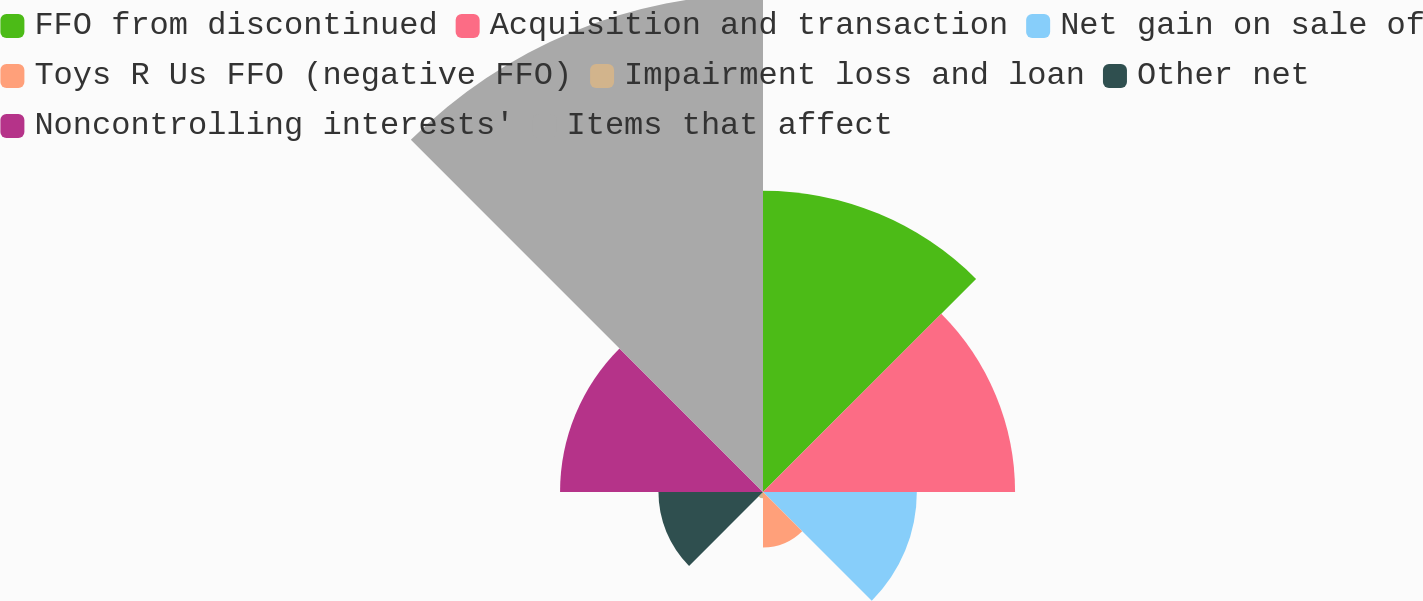<chart> <loc_0><loc_0><loc_500><loc_500><pie_chart><fcel>FFO from discontinued<fcel>Acquisition and transaction<fcel>Net gain on sale of<fcel>Toys R Us FFO (negative FFO)<fcel>Impairment loss and loan<fcel>Other net<fcel>Noncontrolling interests'<fcel>Items that affect<nl><fcel>19.14%<fcel>16.01%<fcel>9.77%<fcel>3.52%<fcel>0.4%<fcel>6.64%<fcel>12.89%<fcel>31.63%<nl></chart> 